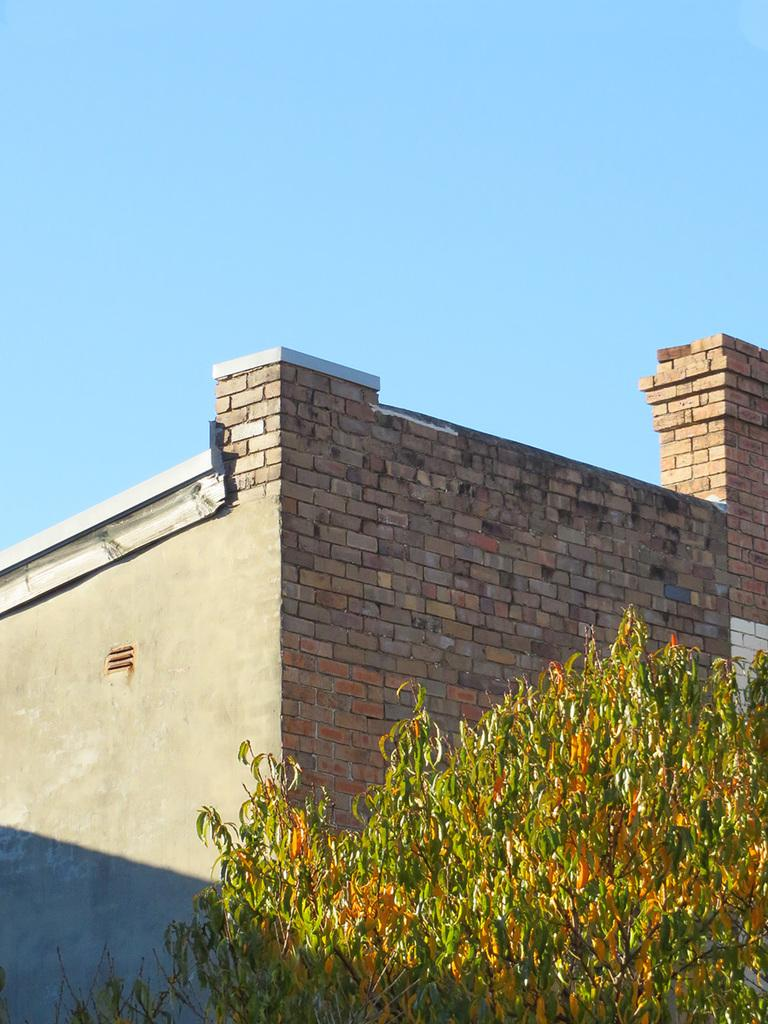What type of structure is present in the image? There is a building in the picture. What natural element can be seen in the image? There is a tree in the picture. What is visible in the background of the image? The sky is visible in the background of the picture. What type of apple is hanging from the tree in the image? There is no apple present in the image; it only features a tree and a building. 